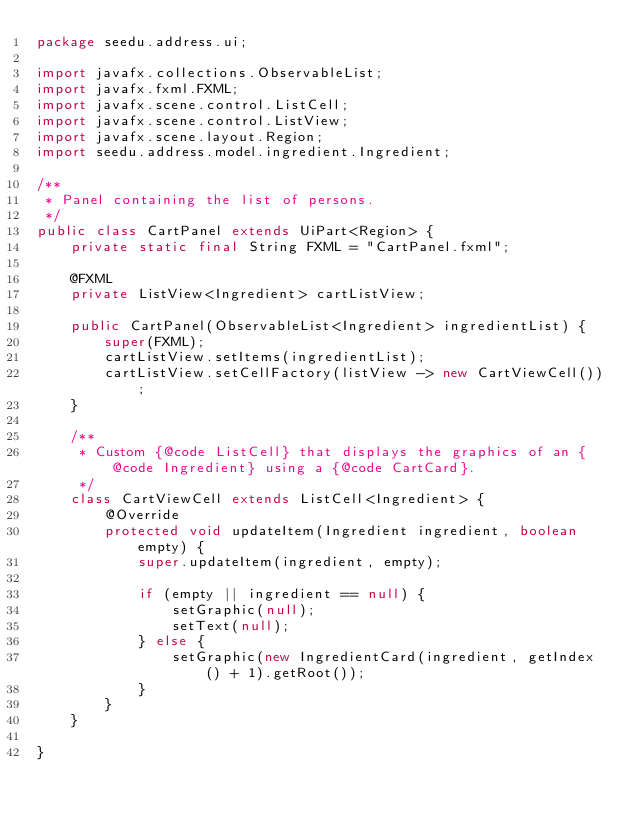<code> <loc_0><loc_0><loc_500><loc_500><_Java_>package seedu.address.ui;

import javafx.collections.ObservableList;
import javafx.fxml.FXML;
import javafx.scene.control.ListCell;
import javafx.scene.control.ListView;
import javafx.scene.layout.Region;
import seedu.address.model.ingredient.Ingredient;

/**
 * Panel containing the list of persons.
 */
public class CartPanel extends UiPart<Region> {
    private static final String FXML = "CartPanel.fxml";

    @FXML
    private ListView<Ingredient> cartListView;

    public CartPanel(ObservableList<Ingredient> ingredientList) {
        super(FXML);
        cartListView.setItems(ingredientList);
        cartListView.setCellFactory(listView -> new CartViewCell());
    }

    /**
     * Custom {@code ListCell} that displays the graphics of an {@code Ingredient} using a {@code CartCard}.
     */
    class CartViewCell extends ListCell<Ingredient> {
        @Override
        protected void updateItem(Ingredient ingredient, boolean empty) {
            super.updateItem(ingredient, empty);

            if (empty || ingredient == null) {
                setGraphic(null);
                setText(null);
            } else {
                setGraphic(new IngredientCard(ingredient, getIndex() + 1).getRoot());
            }
        }
    }

}
</code> 